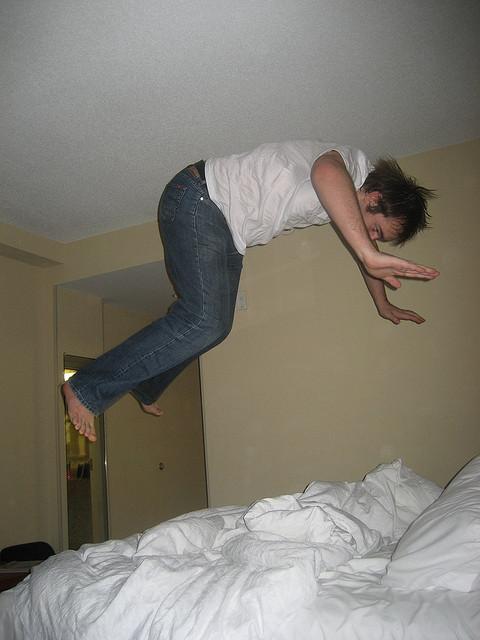What color is the wall?
Quick response, please. Beige. Is there a telephone?
Give a very brief answer. No. Is this person touching the ceiling?
Give a very brief answer. No. How tall is the person?
Keep it brief. 6 feet. 